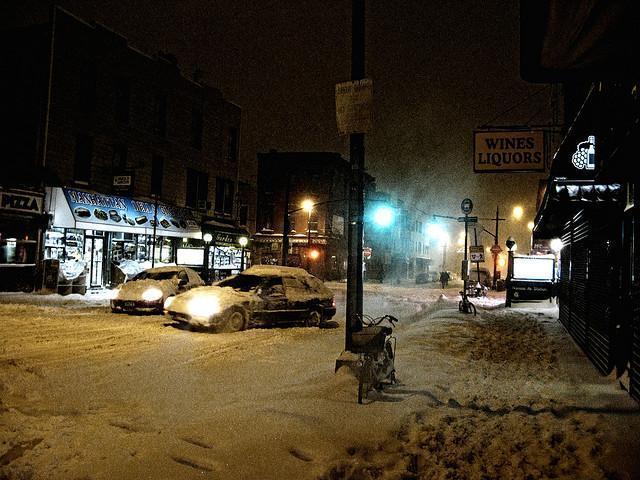How many cars are there?
Give a very brief answer. 2. How many bicycles can you see?
Give a very brief answer. 1. How many people are wearing blue shorts?
Give a very brief answer. 0. 